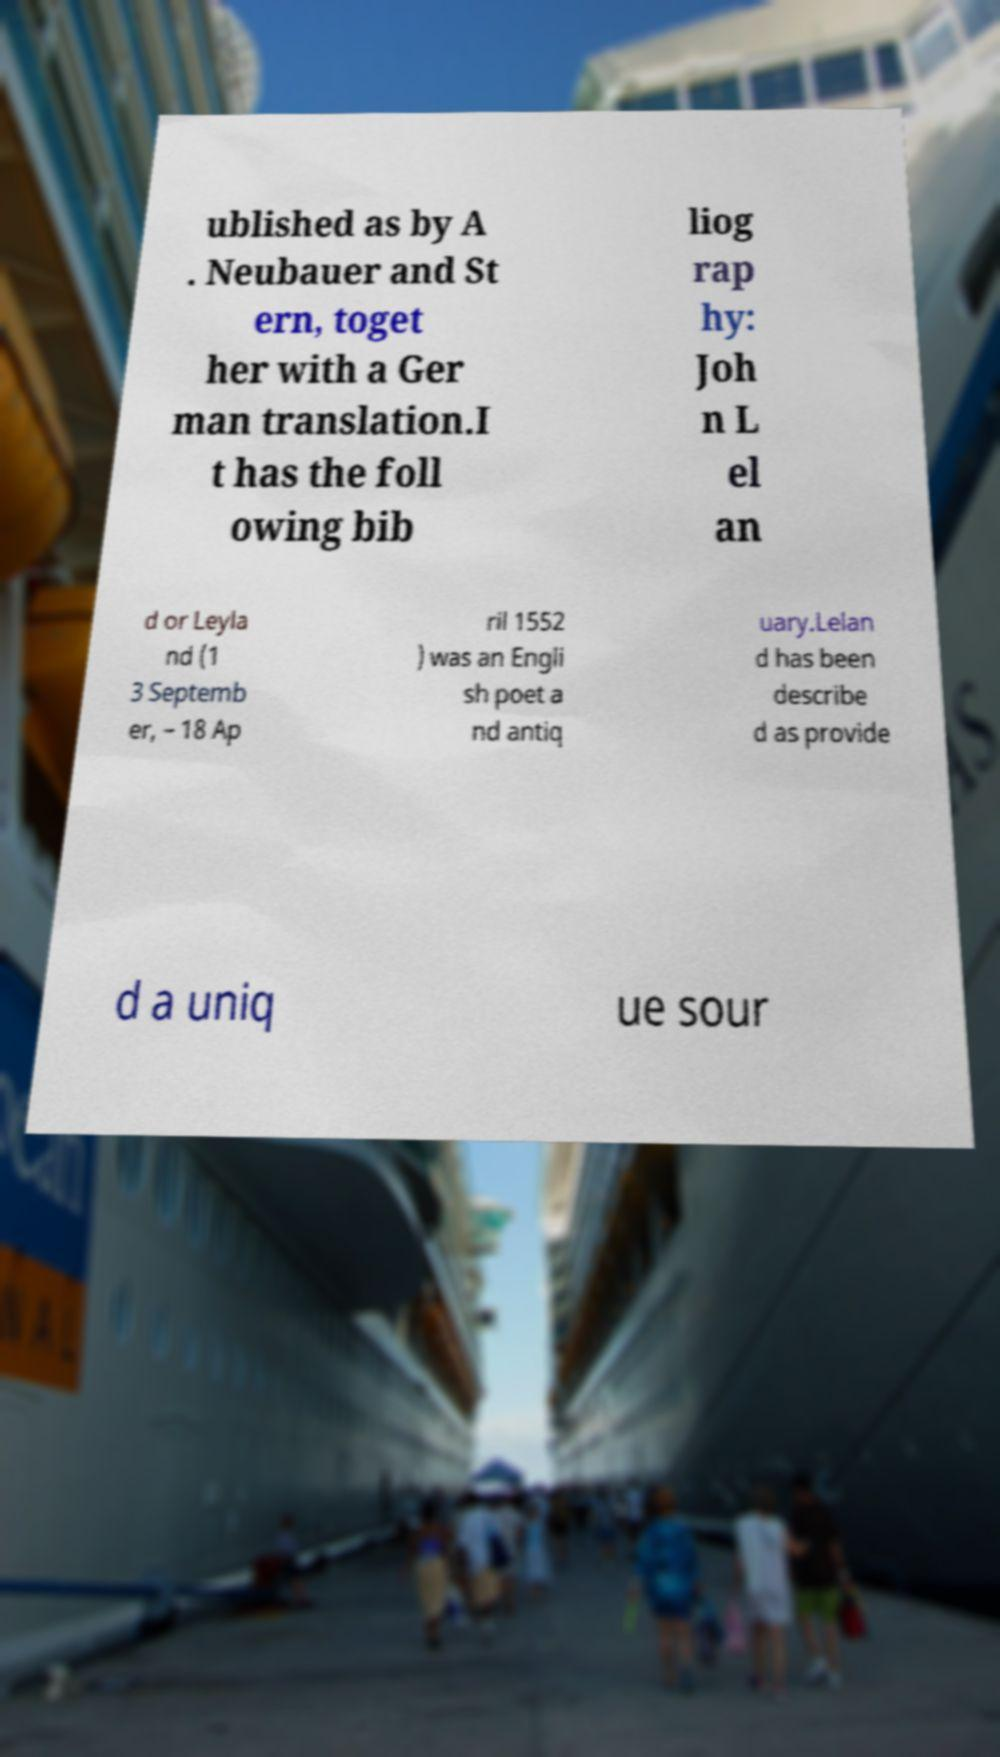For documentation purposes, I need the text within this image transcribed. Could you provide that? ublished as by A . Neubauer and St ern, toget her with a Ger man translation.I t has the foll owing bib liog rap hy: Joh n L el an d or Leyla nd (1 3 Septemb er, – 18 Ap ril 1552 ) was an Engli sh poet a nd antiq uary.Lelan d has been describe d as provide d a uniq ue sour 